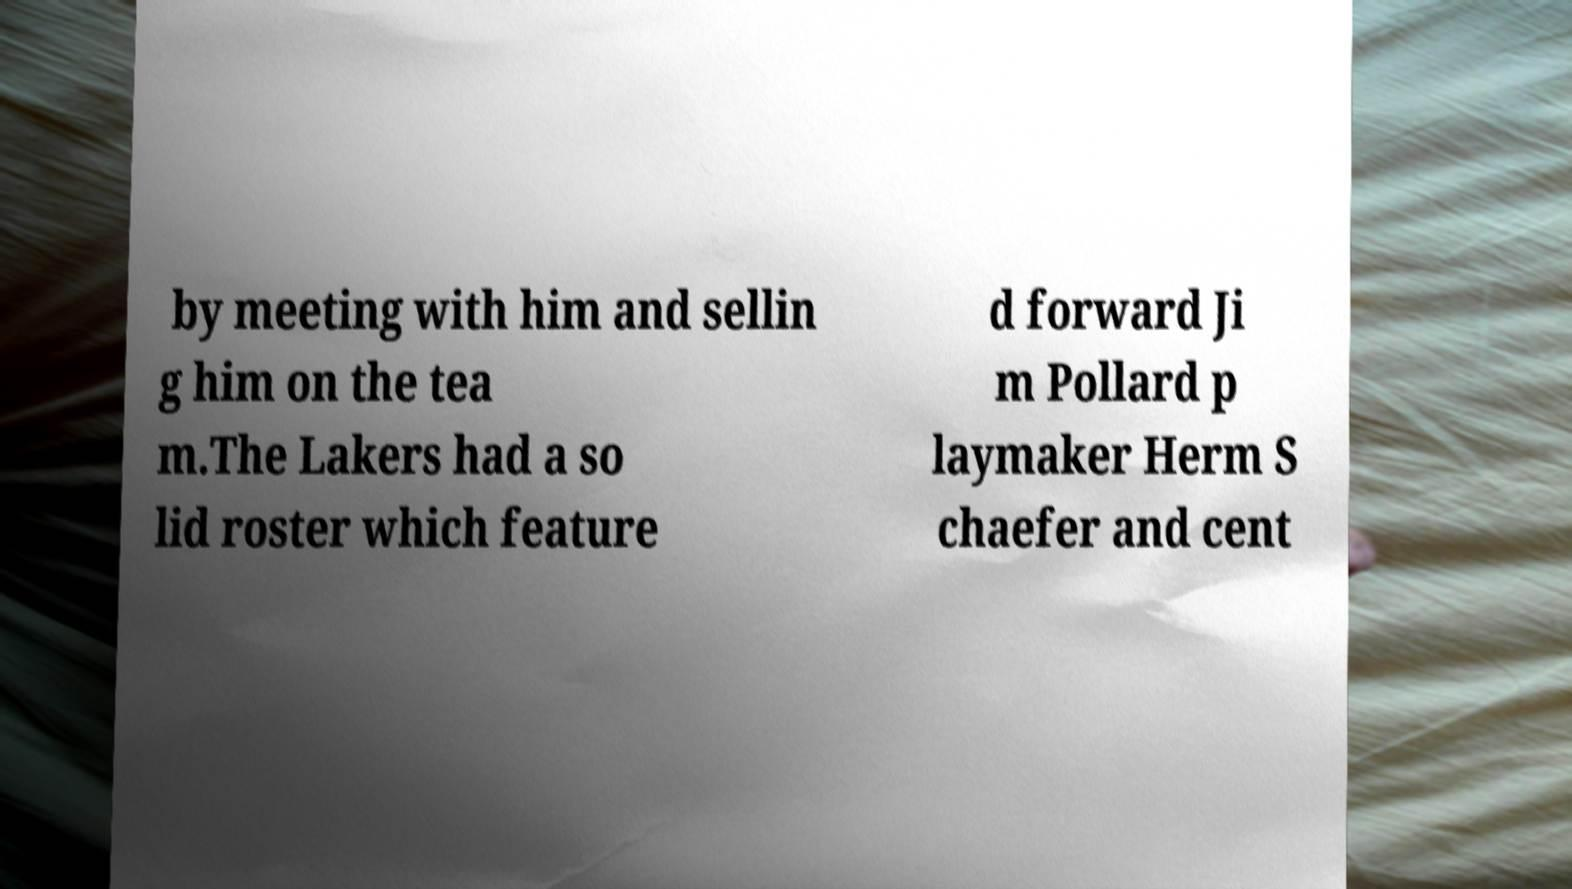I need the written content from this picture converted into text. Can you do that? by meeting with him and sellin g him on the tea m.The Lakers had a so lid roster which feature d forward Ji m Pollard p laymaker Herm S chaefer and cent 